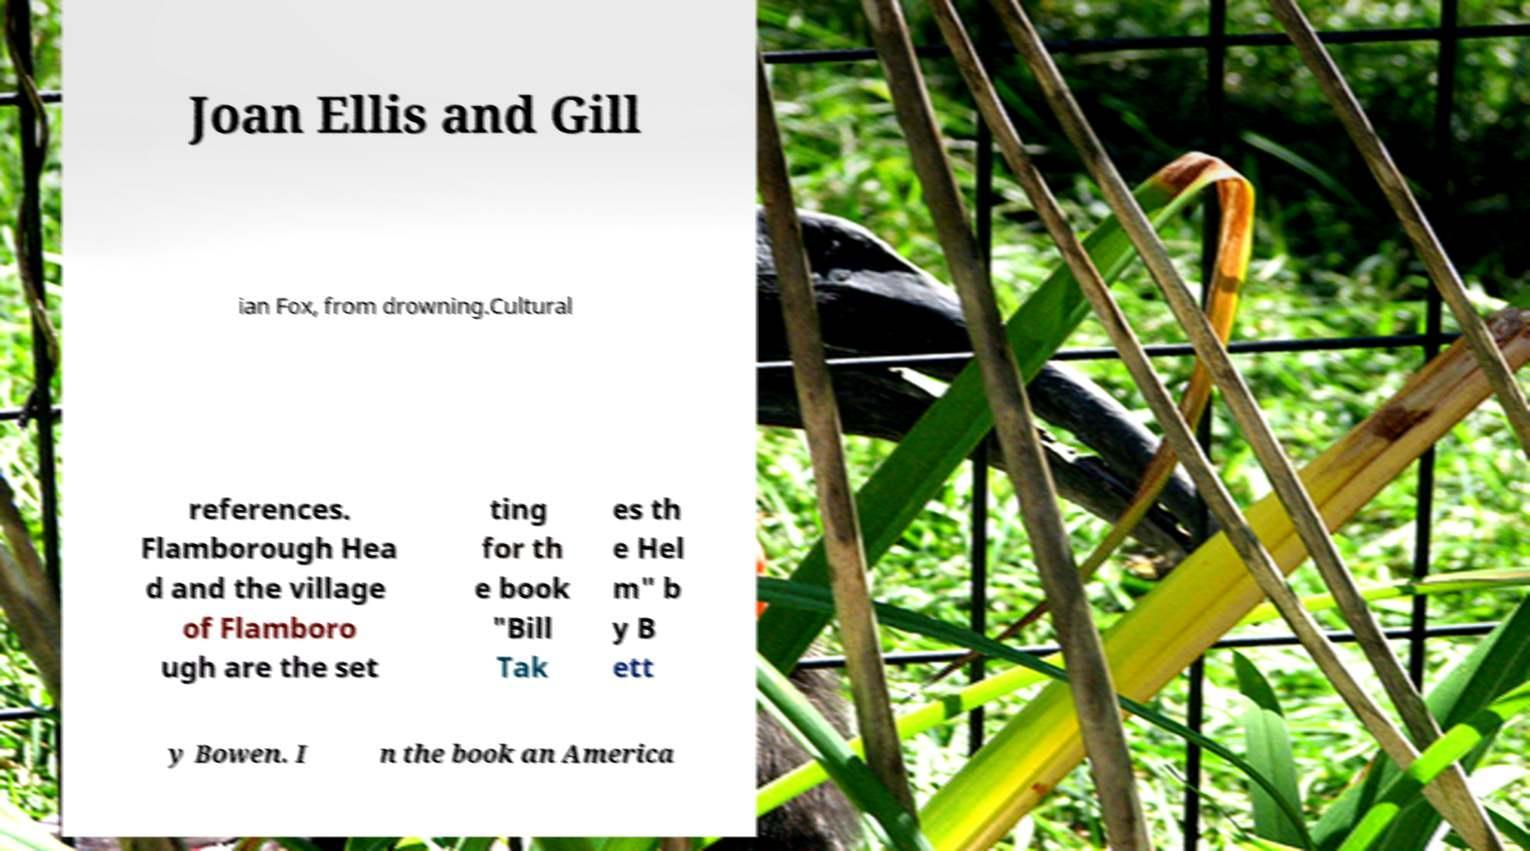I need the written content from this picture converted into text. Can you do that? Joan Ellis and Gill ian Fox, from drowning.Cultural references. Flamborough Hea d and the village of Flamboro ugh are the set ting for th e book "Bill Tak es th e Hel m" b y B ett y Bowen. I n the book an America 